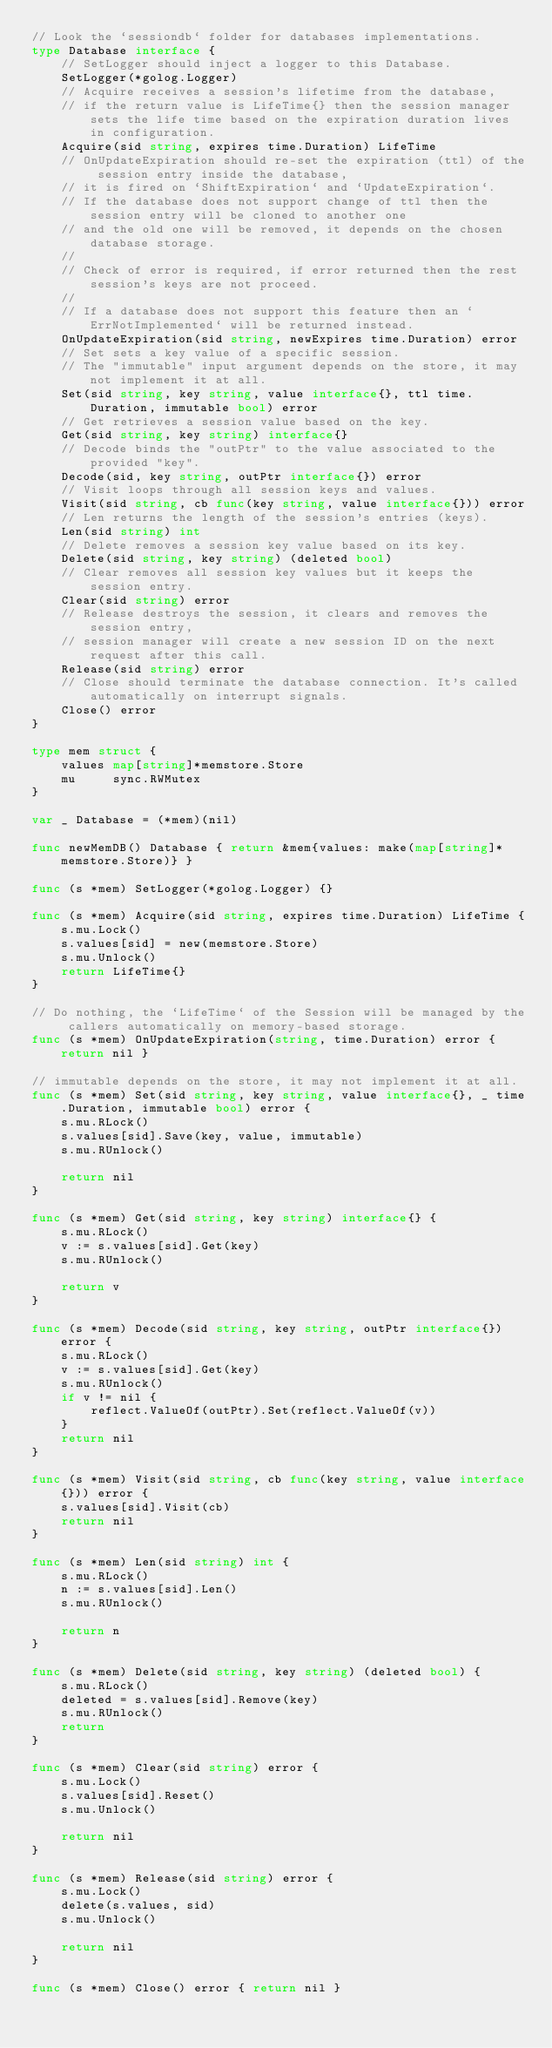Convert code to text. <code><loc_0><loc_0><loc_500><loc_500><_Go_>// Look the `sessiondb` folder for databases implementations.
type Database interface {
	// SetLogger should inject a logger to this Database.
	SetLogger(*golog.Logger)
	// Acquire receives a session's lifetime from the database,
	// if the return value is LifeTime{} then the session manager sets the life time based on the expiration duration lives in configuration.
	Acquire(sid string, expires time.Duration) LifeTime
	// OnUpdateExpiration should re-set the expiration (ttl) of the session entry inside the database,
	// it is fired on `ShiftExpiration` and `UpdateExpiration`.
	// If the database does not support change of ttl then the session entry will be cloned to another one
	// and the old one will be removed, it depends on the chosen database storage.
	//
	// Check of error is required, if error returned then the rest session's keys are not proceed.
	//
	// If a database does not support this feature then an `ErrNotImplemented` will be returned instead.
	OnUpdateExpiration(sid string, newExpires time.Duration) error
	// Set sets a key value of a specific session.
	// The "immutable" input argument depends on the store, it may not implement it at all.
	Set(sid string, key string, value interface{}, ttl time.Duration, immutable bool) error
	// Get retrieves a session value based on the key.
	Get(sid string, key string) interface{}
	// Decode binds the "outPtr" to the value associated to the provided "key".
	Decode(sid, key string, outPtr interface{}) error
	// Visit loops through all session keys and values.
	Visit(sid string, cb func(key string, value interface{})) error
	// Len returns the length of the session's entries (keys).
	Len(sid string) int
	// Delete removes a session key value based on its key.
	Delete(sid string, key string) (deleted bool)
	// Clear removes all session key values but it keeps the session entry.
	Clear(sid string) error
	// Release destroys the session, it clears and removes the session entry,
	// session manager will create a new session ID on the next request after this call.
	Release(sid string) error
	// Close should terminate the database connection. It's called automatically on interrupt signals.
	Close() error
}

type mem struct {
	values map[string]*memstore.Store
	mu     sync.RWMutex
}

var _ Database = (*mem)(nil)

func newMemDB() Database { return &mem{values: make(map[string]*memstore.Store)} }

func (s *mem) SetLogger(*golog.Logger) {}

func (s *mem) Acquire(sid string, expires time.Duration) LifeTime {
	s.mu.Lock()
	s.values[sid] = new(memstore.Store)
	s.mu.Unlock()
	return LifeTime{}
}

// Do nothing, the `LifeTime` of the Session will be managed by the callers automatically on memory-based storage.
func (s *mem) OnUpdateExpiration(string, time.Duration) error { return nil }

// immutable depends on the store, it may not implement it at all.
func (s *mem) Set(sid string, key string, value interface{}, _ time.Duration, immutable bool) error {
	s.mu.RLock()
	s.values[sid].Save(key, value, immutable)
	s.mu.RUnlock()

	return nil
}

func (s *mem) Get(sid string, key string) interface{} {
	s.mu.RLock()
	v := s.values[sid].Get(key)
	s.mu.RUnlock()

	return v
}

func (s *mem) Decode(sid string, key string, outPtr interface{}) error {
	s.mu.RLock()
	v := s.values[sid].Get(key)
	s.mu.RUnlock()
	if v != nil {
		reflect.ValueOf(outPtr).Set(reflect.ValueOf(v))
	}
	return nil
}

func (s *mem) Visit(sid string, cb func(key string, value interface{})) error {
	s.values[sid].Visit(cb)
	return nil
}

func (s *mem) Len(sid string) int {
	s.mu.RLock()
	n := s.values[sid].Len()
	s.mu.RUnlock()

	return n
}

func (s *mem) Delete(sid string, key string) (deleted bool) {
	s.mu.RLock()
	deleted = s.values[sid].Remove(key)
	s.mu.RUnlock()
	return
}

func (s *mem) Clear(sid string) error {
	s.mu.Lock()
	s.values[sid].Reset()
	s.mu.Unlock()

	return nil
}

func (s *mem) Release(sid string) error {
	s.mu.Lock()
	delete(s.values, sid)
	s.mu.Unlock()

	return nil
}

func (s *mem) Close() error { return nil }
</code> 